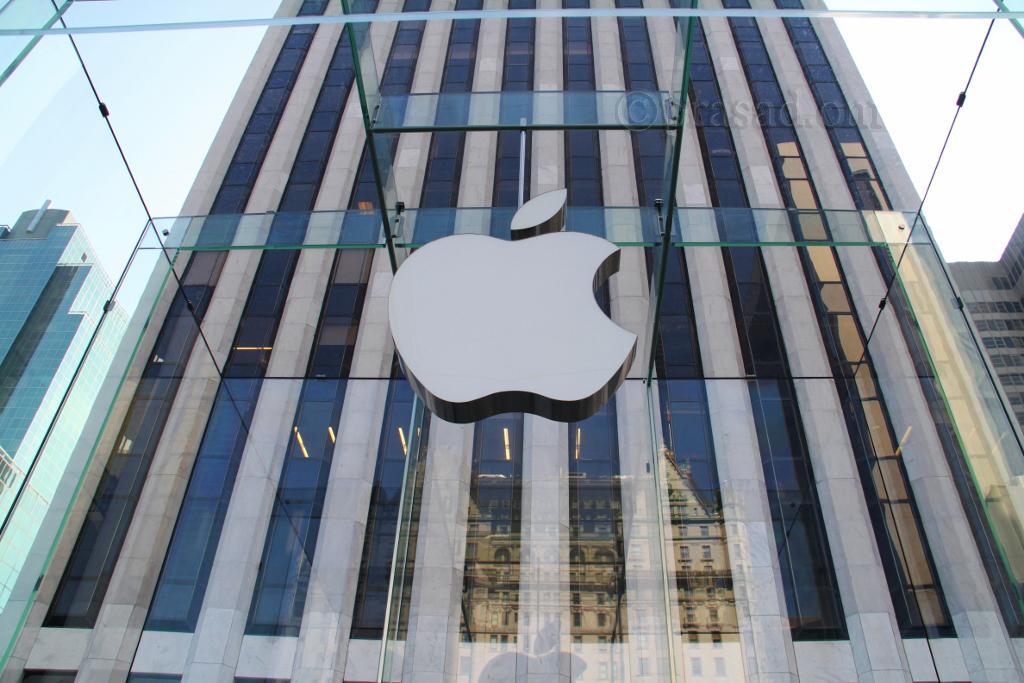In one or two sentences, can you explain what this image depicts? In this picture we can see the skyscrapers. We can see a logo. On the glass we can see the reflection of a building. 